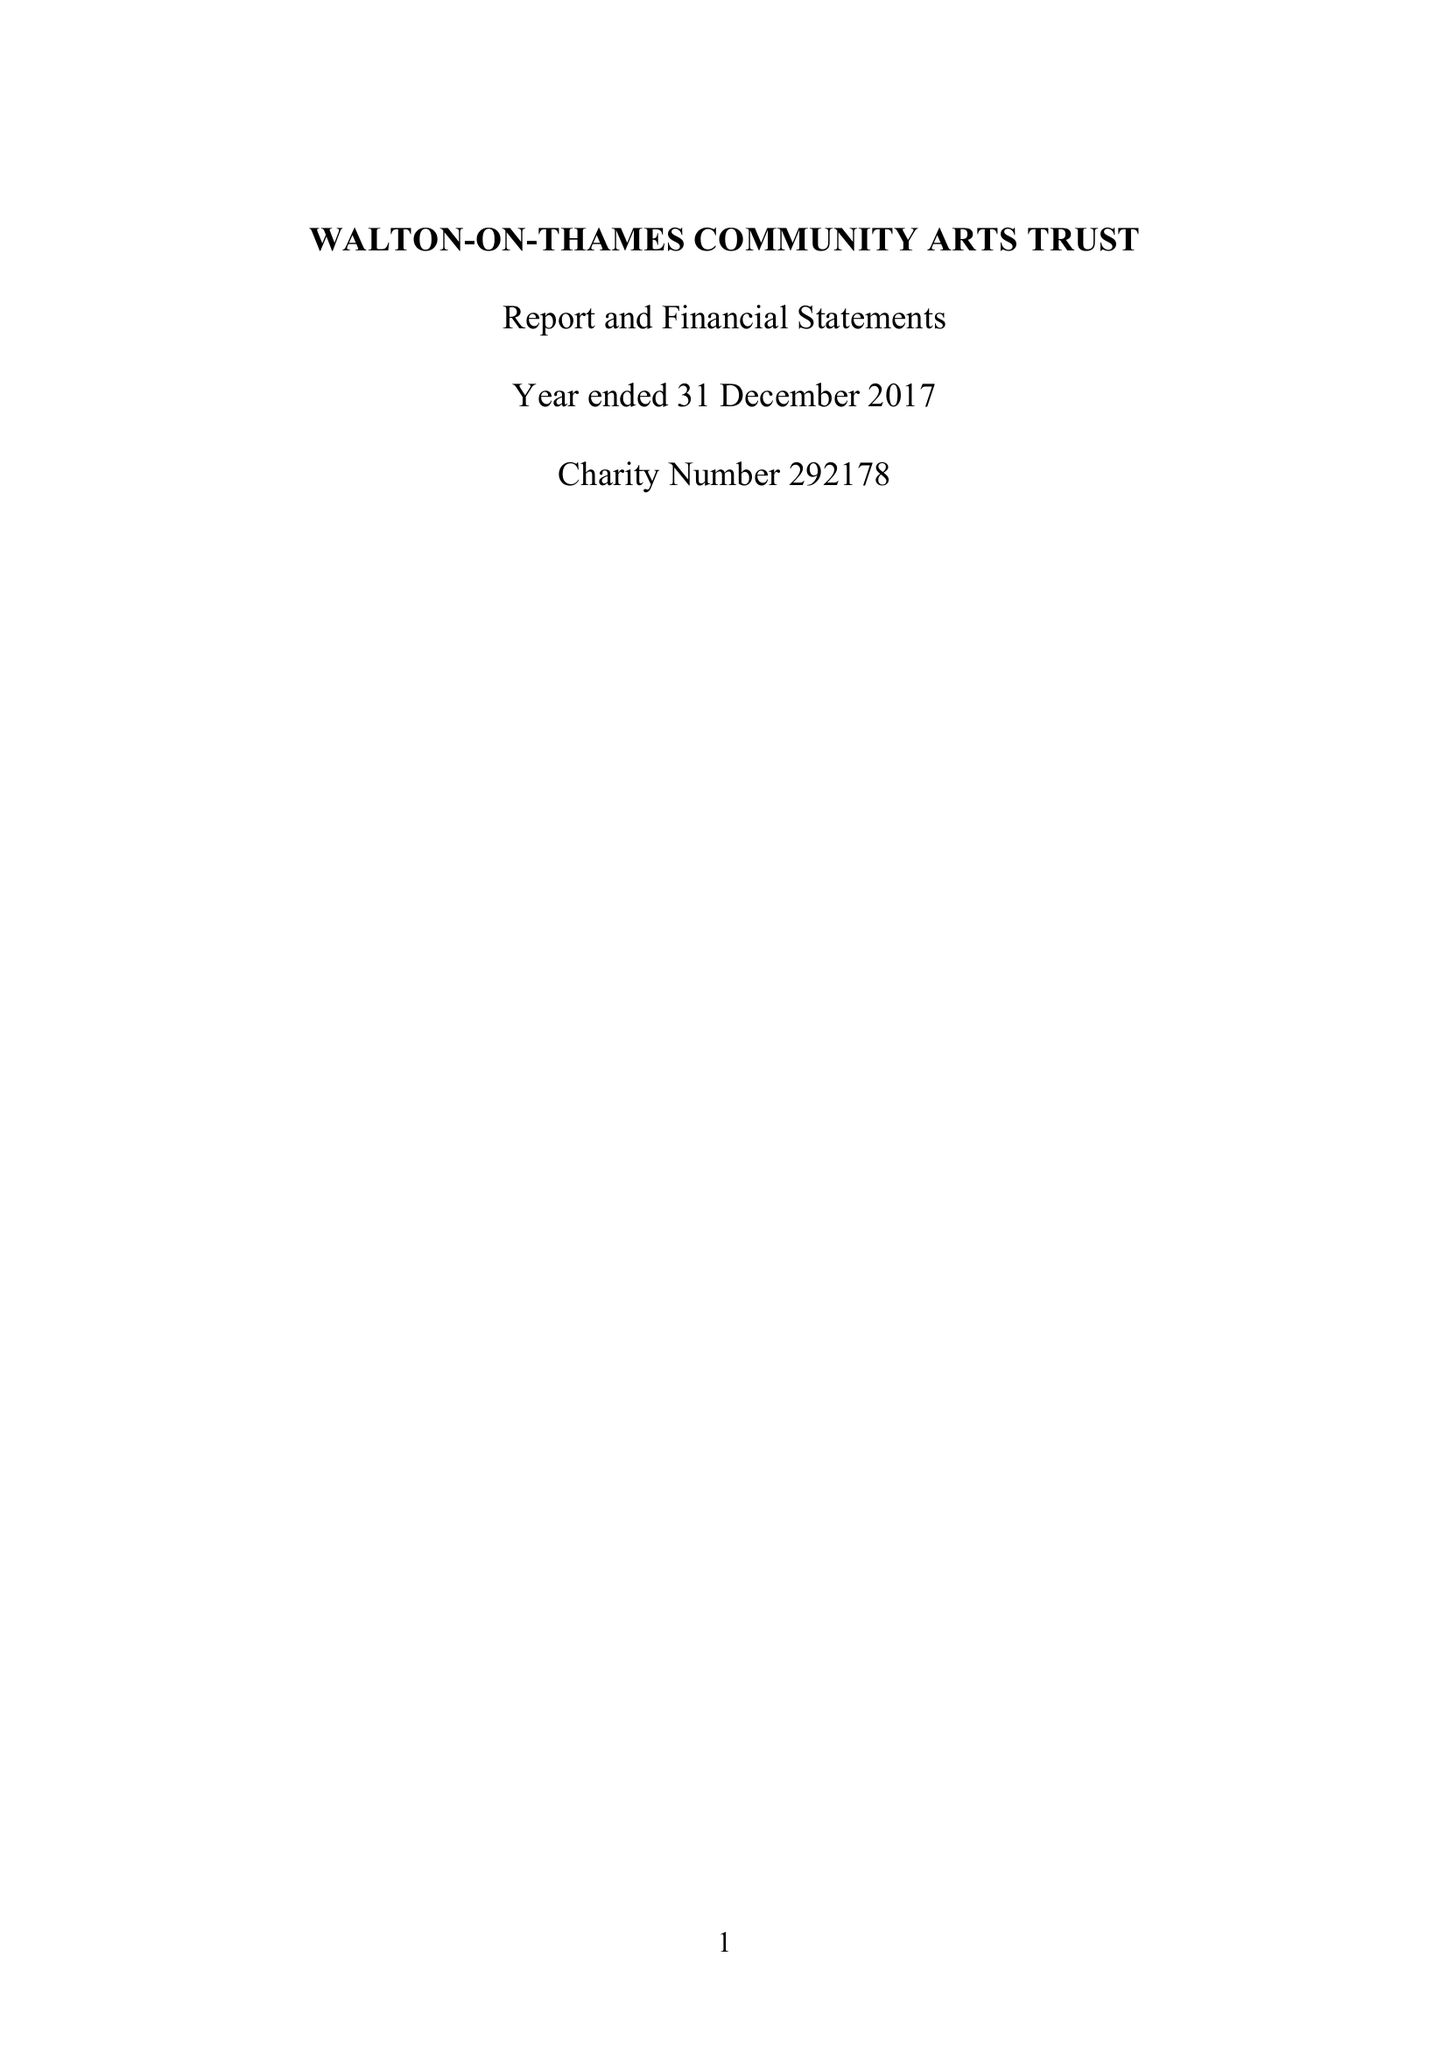What is the value for the report_date?
Answer the question using a single word or phrase. 2017-12-31 